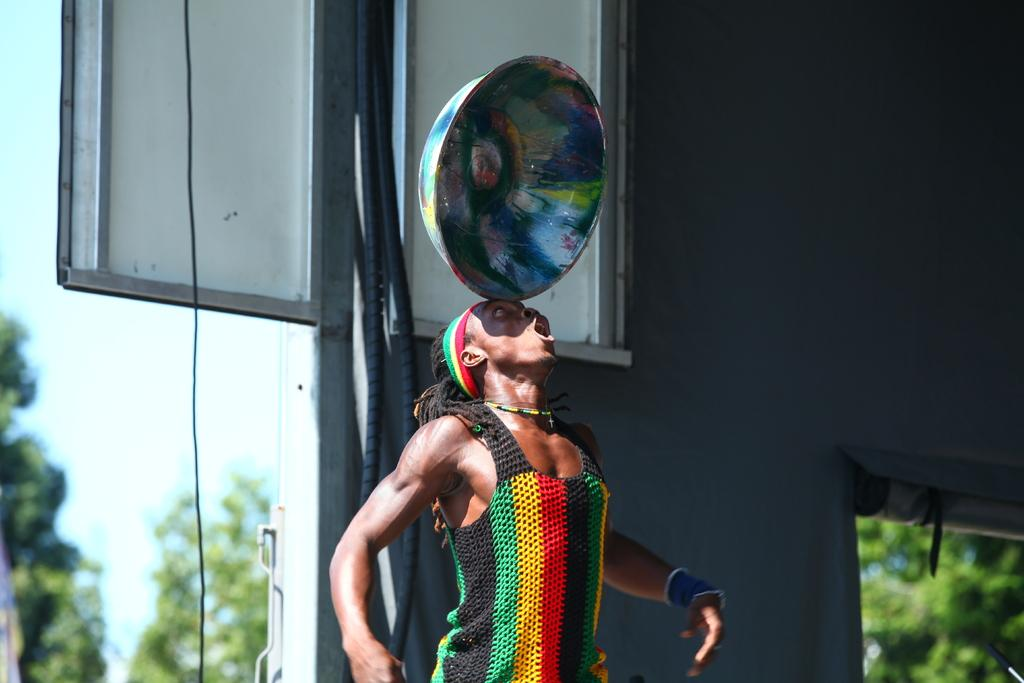What is the person in the image wearing? The person is wearing a colorful dress in the image. What unusual object is the person holding on their head? The person has a bowl on their head. What can be seen in the background of the image? There is a board, a wall, many trees, and the sky visible in the background of the image. What type of dirt can be seen on the chair in the image? There is no chair present in the image, so it is not possible to determine if there is any dirt on it. 